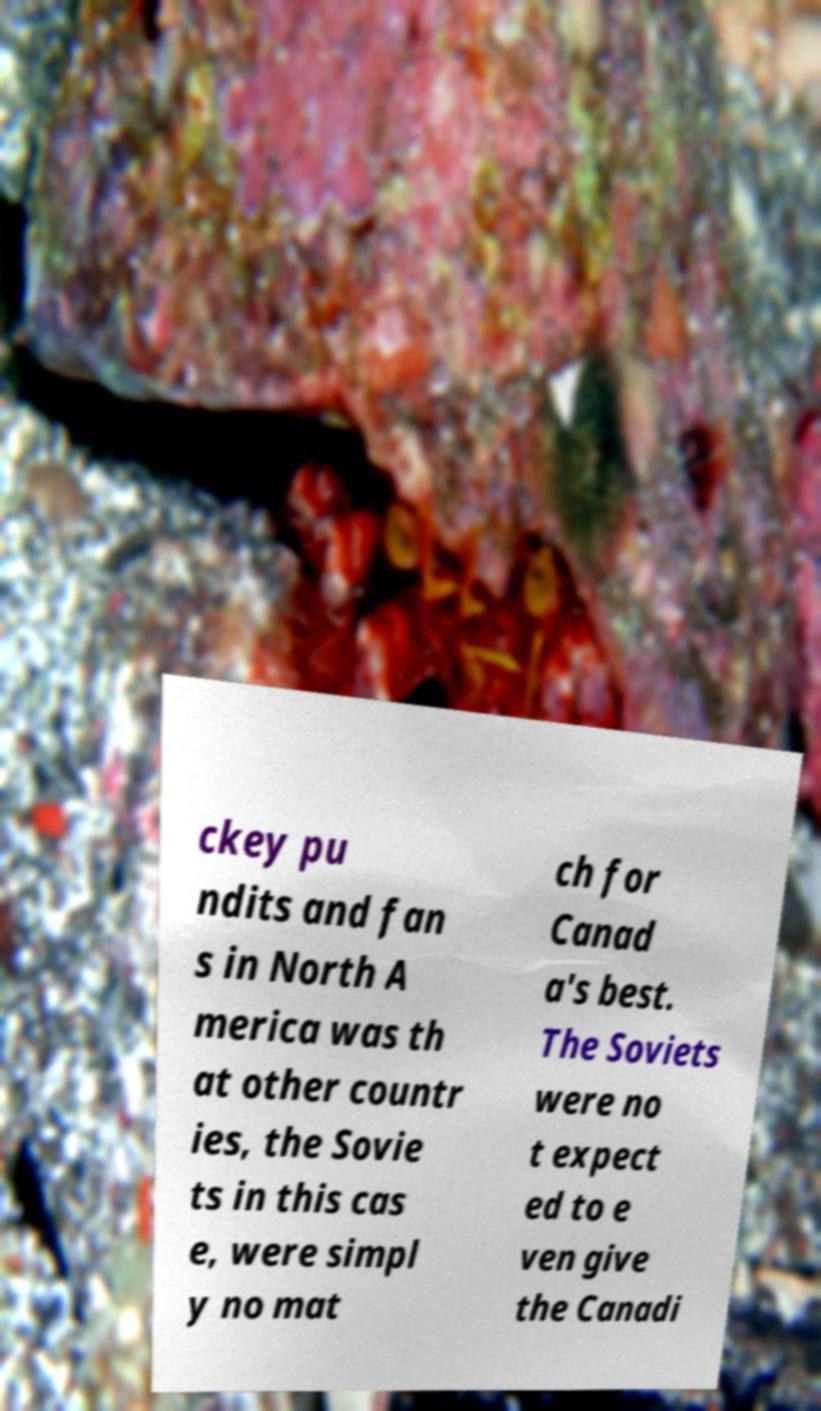Can you accurately transcribe the text from the provided image for me? ckey pu ndits and fan s in North A merica was th at other countr ies, the Sovie ts in this cas e, were simpl y no mat ch for Canad a's best. The Soviets were no t expect ed to e ven give the Canadi 